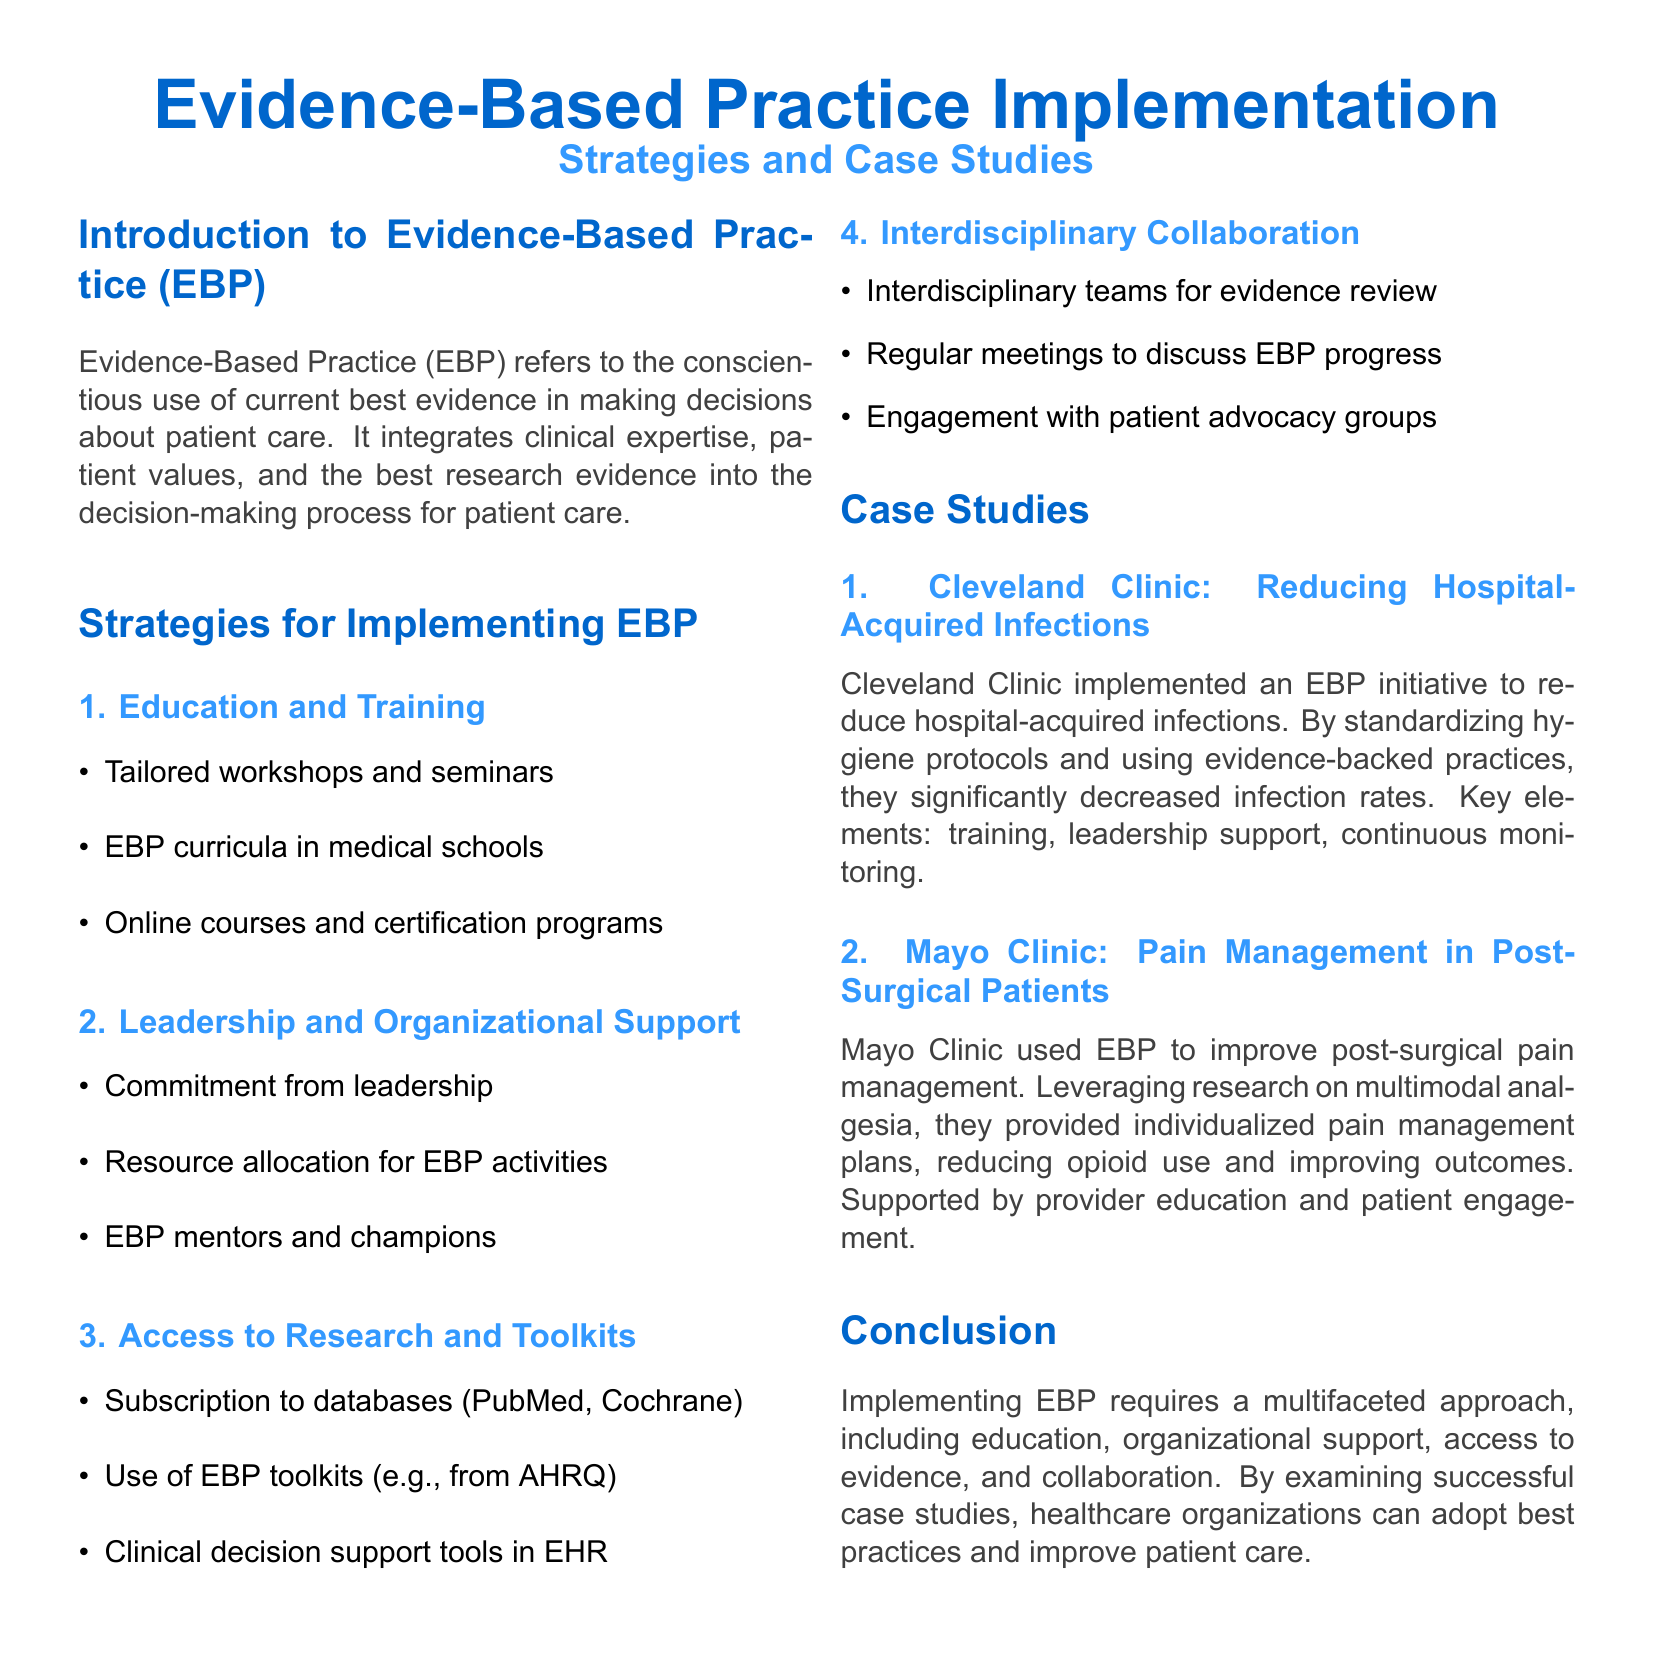What is the title of the document? The title of the document is prominently displayed at the beginning, indicating that it is a guide about EBP implementation.
Answer: Evidence-Based Practice Implementation How many strategies are listed for implementing EBP? The document outlines four distinct strategies for implementing EBP.
Answer: 4 What case study is mentioned regarding hospital-acquired infections? The document provides a specific example related to hospital-acquired infections as part of the case studies section.
Answer: Cleveland Clinic Which organization focused on pain management in post-surgical patients? The case study section details an initiative regarding pain management and identifies the organization involved.
Answer: Mayo Clinic What type of workshops are suggested in the education and training strategy? The document specifies tailored workshops as a component of the education and training strategy for EBP implementation.
Answer: Tailored workshops What is essential for EBP according to the conclusion? The conclusion emphasizes a specific approach that is necessary for successful EBP implementation across healthcare organizations.
Answer: Multifaceted approach 